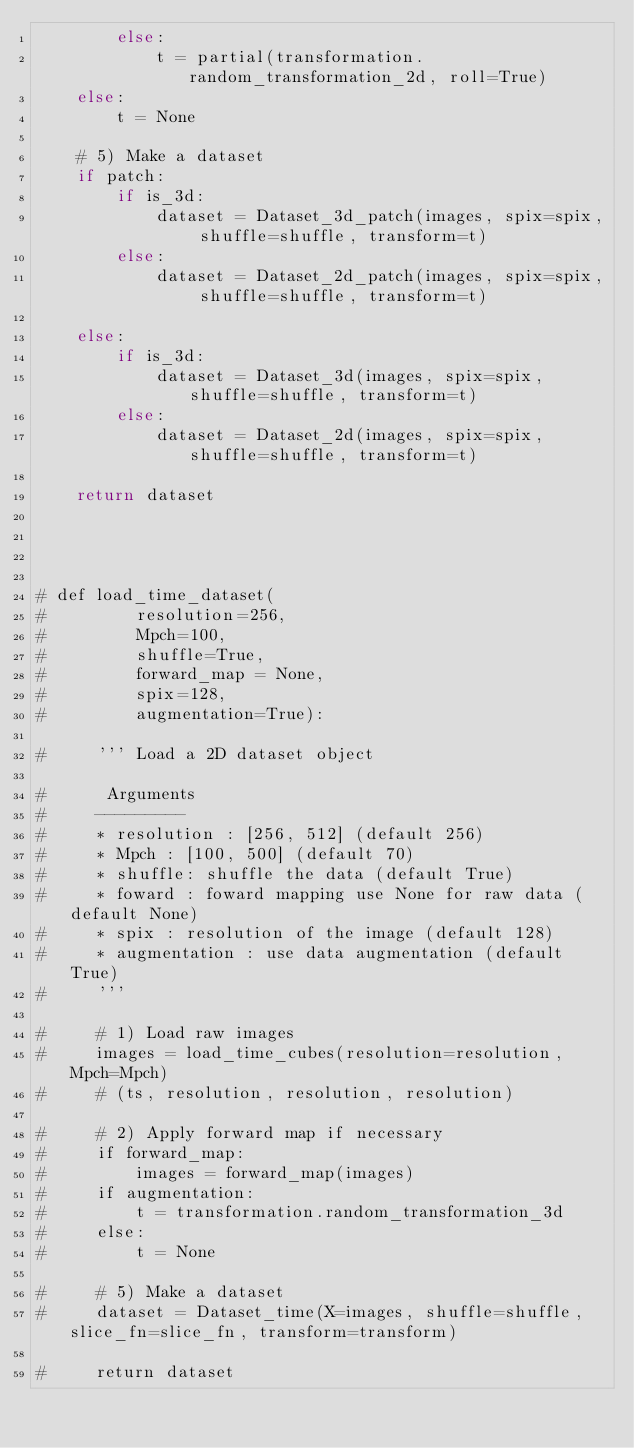<code> <loc_0><loc_0><loc_500><loc_500><_Python_>        else:
            t = partial(transformation.random_transformation_2d, roll=True)
    else:
        t = None
    
    # 5) Make a dataset
    if patch:
        if is_3d:
            dataset = Dataset_3d_patch(images, spix=spix, shuffle=shuffle, transform=t)
        else:
            dataset = Dataset_2d_patch(images, spix=spix, shuffle=shuffle, transform=t)

    else:
        if is_3d:
            dataset = Dataset_3d(images, spix=spix, shuffle=shuffle, transform=t)
        else:
            dataset = Dataset_2d(images, spix=spix, shuffle=shuffle, transform=t)

    return dataset



    
# def load_time_dataset(
#         resolution=256,
#         Mpch=100,
#         shuffle=True,
#         forward_map = None,
#         spix=128,
#         augmentation=True):

#     ''' Load a 2D dataset object 

#      Arguments
#     ---------
#     * resolution : [256, 512] (default 256)
#     * Mpch : [100, 500] (default 70)
#     * shuffle: shuffle the data (default True)
#     * foward : foward mapping use None for raw data (default None)
#     * spix : resolution of the image (default 128)
#     * augmentation : use data augmentation (default True)
#     '''

#     # 1) Load raw images
#     images = load_time_cubes(resolution=resolution, Mpch=Mpch)
#     # (ts, resolution, resolution, resolution)

#     # 2) Apply forward map if necessary
#     if forward_map:
#         images = forward_map(images)
#     if augmentation:
#         t = transformation.random_transformation_3d
#     else:
#         t = None

#     # 5) Make a dataset
#     dataset = Dataset_time(X=images, shuffle=shuffle, slice_fn=slice_fn, transform=transform)

#     return dataset
</code> 